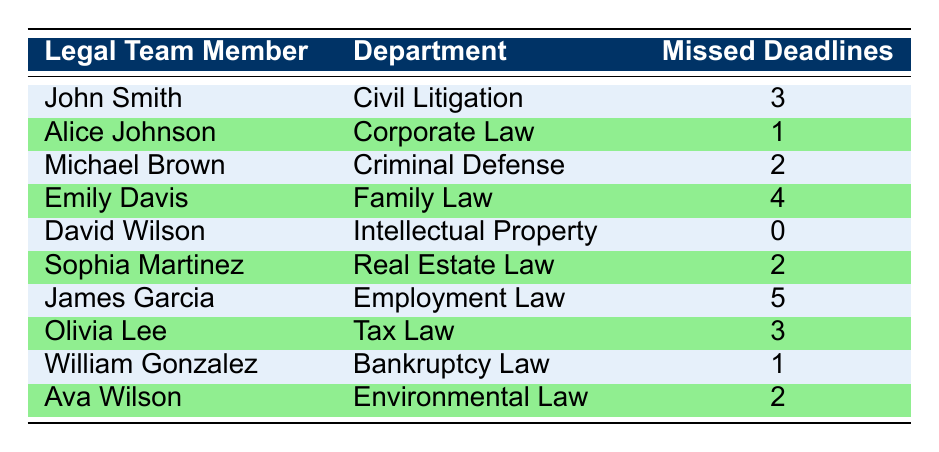What is the total number of missed deadlines by James Garcia? James Garcia has a missed deadline count of 5 as directly stated in the table.
Answer: 5 Which legal team member missed the most deadlines? Emily Davis and James Garcia both missed deadlines, but James Garcia has the highest count of 5 missed deadlines, which is the maximum among all team members.
Answer: James Garcia What is the average number of missed deadlines across all legal team members? The total number of missed deadlines is 3 + 1 + 2 + 4 + 0 + 2 + 5 + 3 + 1 + 2 = 23. There are 10 legal team members, so the average is 23/10 = 2.3.
Answer: 2.3 Did any legal team member not miss any deadlines? Looking at the table, David Wilson has a missed deadline count of 0, indicating he did not miss any deadlines.
Answer: Yes How many legal team members missed more than 2 deadlines? The members who missed more than 2 deadlines are James Garcia (5), Emily Davis (4), and John Smith (3). This makes a total of 3 members.
Answer: 3 What is the difference in missed deadlines between the member with the highest and the member with the lowest count? James Garcia has 5 missed deadlines (highest) and David Wilson has 0 missed deadlines (lowest). The difference is 5 - 0 = 5.
Answer: 5 Which department has the legal team member with the lowest count of missed deadlines? David Wilson from the Intellectual Property department has the lowest count of missed deadlines, which is 0.
Answer: Intellectual Property If we combine the missed deadlines of Sophia Martinez and Ava Wilson, what is the total? Sophia Martinez has 2 missed deadlines and Ava Wilson also has 2. Therefore, the total is 2 + 2 = 4.
Answer: 4 How many members missed 2 deadlines? The members who missed exactly 2 deadlines are Michael Brown, Sophia Martinez, and Ava Wilson. Thus, there are 3 members.
Answer: 3 